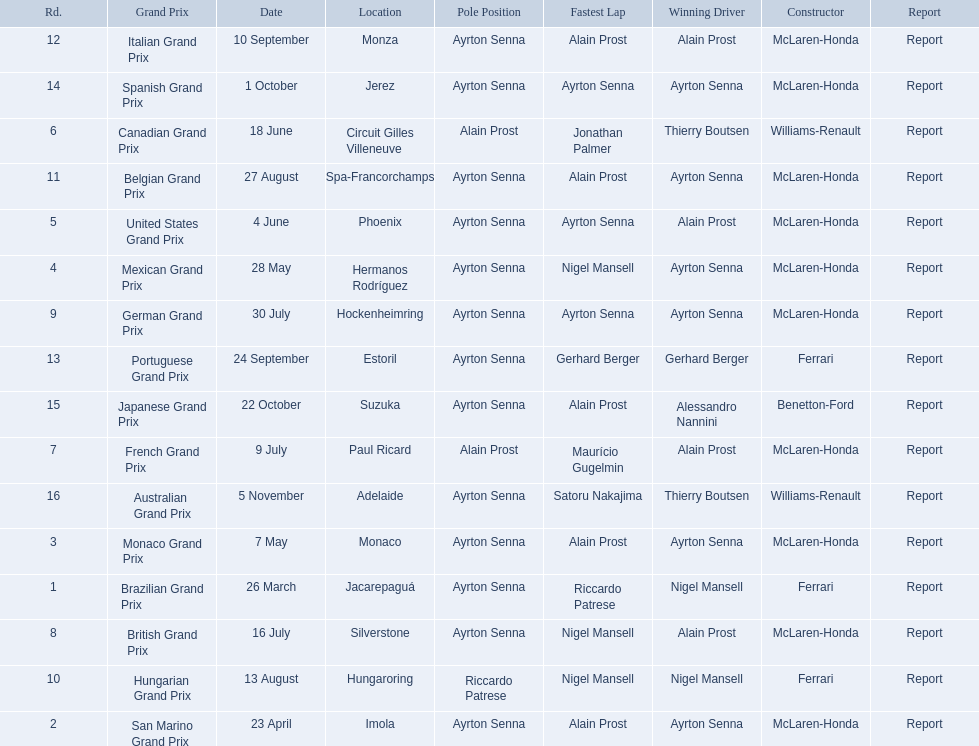Who are the constructors in the 1989 formula one season? Ferrari, McLaren-Honda, McLaren-Honda, McLaren-Honda, McLaren-Honda, Williams-Renault, McLaren-Honda, McLaren-Honda, McLaren-Honda, Ferrari, McLaren-Honda, McLaren-Honda, Ferrari, McLaren-Honda, Benetton-Ford, Williams-Renault. On what date was bennington ford the constructor? 22 October. Could you help me parse every detail presented in this table? {'header': ['Rd.', 'Grand Prix', 'Date', 'Location', 'Pole Position', 'Fastest Lap', 'Winning Driver', 'Constructor', 'Report'], 'rows': [['12', 'Italian Grand Prix', '10 September', 'Monza', 'Ayrton Senna', 'Alain Prost', 'Alain Prost', 'McLaren-Honda', 'Report'], ['14', 'Spanish Grand Prix', '1 October', 'Jerez', 'Ayrton Senna', 'Ayrton Senna', 'Ayrton Senna', 'McLaren-Honda', 'Report'], ['6', 'Canadian Grand Prix', '18 June', 'Circuit Gilles Villeneuve', 'Alain Prost', 'Jonathan Palmer', 'Thierry Boutsen', 'Williams-Renault', 'Report'], ['11', 'Belgian Grand Prix', '27 August', 'Spa-Francorchamps', 'Ayrton Senna', 'Alain Prost', 'Ayrton Senna', 'McLaren-Honda', 'Report'], ['5', 'United States Grand Prix', '4 June', 'Phoenix', 'Ayrton Senna', 'Ayrton Senna', 'Alain Prost', 'McLaren-Honda', 'Report'], ['4', 'Mexican Grand Prix', '28 May', 'Hermanos Rodríguez', 'Ayrton Senna', 'Nigel Mansell', 'Ayrton Senna', 'McLaren-Honda', 'Report'], ['9', 'German Grand Prix', '30 July', 'Hockenheimring', 'Ayrton Senna', 'Ayrton Senna', 'Ayrton Senna', 'McLaren-Honda', 'Report'], ['13', 'Portuguese Grand Prix', '24 September', 'Estoril', 'Ayrton Senna', 'Gerhard Berger', 'Gerhard Berger', 'Ferrari', 'Report'], ['15', 'Japanese Grand Prix', '22 October', 'Suzuka', 'Ayrton Senna', 'Alain Prost', 'Alessandro Nannini', 'Benetton-Ford', 'Report'], ['7', 'French Grand Prix', '9 July', 'Paul Ricard', 'Alain Prost', 'Maurício Gugelmin', 'Alain Prost', 'McLaren-Honda', 'Report'], ['16', 'Australian Grand Prix', '5 November', 'Adelaide', 'Ayrton Senna', 'Satoru Nakajima', 'Thierry Boutsen', 'Williams-Renault', 'Report'], ['3', 'Monaco Grand Prix', '7 May', 'Monaco', 'Ayrton Senna', 'Alain Prost', 'Ayrton Senna', 'McLaren-Honda', 'Report'], ['1', 'Brazilian Grand Prix', '26 March', 'Jacarepaguá', 'Ayrton Senna', 'Riccardo Patrese', 'Nigel Mansell', 'Ferrari', 'Report'], ['8', 'British Grand Prix', '16 July', 'Silverstone', 'Ayrton Senna', 'Nigel Mansell', 'Alain Prost', 'McLaren-Honda', 'Report'], ['10', 'Hungarian Grand Prix', '13 August', 'Hungaroring', 'Riccardo Patrese', 'Nigel Mansell', 'Nigel Mansell', 'Ferrari', 'Report'], ['2', 'San Marino Grand Prix', '23 April', 'Imola', 'Ayrton Senna', 'Alain Prost', 'Ayrton Senna', 'McLaren-Honda', 'Report']]} What was the race on october 22? Japanese Grand Prix. 